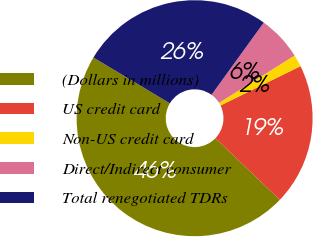Convert chart to OTSL. <chart><loc_0><loc_0><loc_500><loc_500><pie_chart><fcel>(Dollars in millions)<fcel>US credit card<fcel>Non-US credit card<fcel>Direct/Indirect consumer<fcel>Total renegotiated TDRs<nl><fcel>46.44%<fcel>19.43%<fcel>1.64%<fcel>6.12%<fcel>26.37%<nl></chart> 